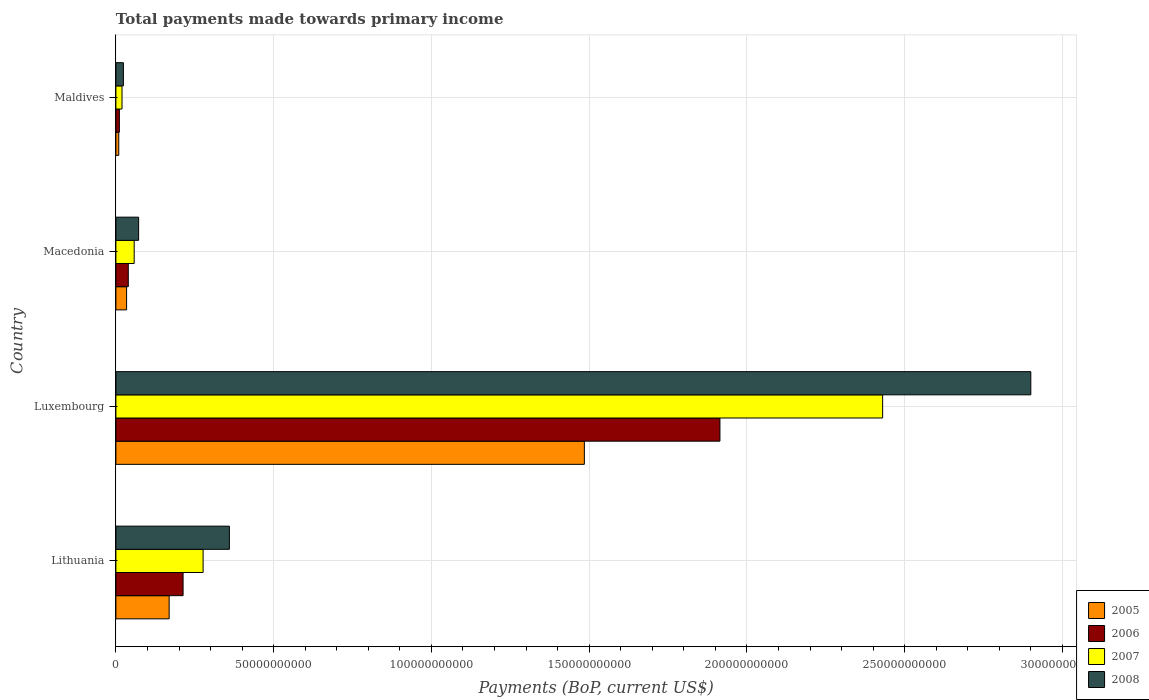How many groups of bars are there?
Offer a terse response. 4. Are the number of bars on each tick of the Y-axis equal?
Offer a very short reply. Yes. How many bars are there on the 4th tick from the top?
Offer a terse response. 4. How many bars are there on the 2nd tick from the bottom?
Give a very brief answer. 4. What is the label of the 2nd group of bars from the top?
Your answer should be compact. Macedonia. In how many cases, is the number of bars for a given country not equal to the number of legend labels?
Give a very brief answer. 0. What is the total payments made towards primary income in 2005 in Lithuania?
Keep it short and to the point. 1.69e+1. Across all countries, what is the maximum total payments made towards primary income in 2008?
Your response must be concise. 2.90e+11. Across all countries, what is the minimum total payments made towards primary income in 2008?
Make the answer very short. 2.38e+09. In which country was the total payments made towards primary income in 2007 maximum?
Make the answer very short. Luxembourg. In which country was the total payments made towards primary income in 2007 minimum?
Ensure brevity in your answer.  Maldives. What is the total total payments made towards primary income in 2005 in the graph?
Your answer should be very brief. 1.70e+11. What is the difference between the total payments made towards primary income in 2008 in Luxembourg and that in Macedonia?
Ensure brevity in your answer.  2.83e+11. What is the difference between the total payments made towards primary income in 2008 in Maldives and the total payments made towards primary income in 2006 in Lithuania?
Your response must be concise. -1.89e+1. What is the average total payments made towards primary income in 2005 per country?
Offer a terse response. 4.24e+1. What is the difference between the total payments made towards primary income in 2005 and total payments made towards primary income in 2006 in Luxembourg?
Make the answer very short. -4.30e+1. In how many countries, is the total payments made towards primary income in 2005 greater than 230000000000 US$?
Provide a short and direct response. 0. What is the ratio of the total payments made towards primary income in 2005 in Lithuania to that in Luxembourg?
Ensure brevity in your answer.  0.11. What is the difference between the highest and the second highest total payments made towards primary income in 2007?
Ensure brevity in your answer.  2.15e+11. What is the difference between the highest and the lowest total payments made towards primary income in 2006?
Your answer should be compact. 1.90e+11. In how many countries, is the total payments made towards primary income in 2005 greater than the average total payments made towards primary income in 2005 taken over all countries?
Keep it short and to the point. 1. Is the sum of the total payments made towards primary income in 2007 in Macedonia and Maldives greater than the maximum total payments made towards primary income in 2008 across all countries?
Ensure brevity in your answer.  No. What does the 1st bar from the bottom in Macedonia represents?
Offer a very short reply. 2005. Is it the case that in every country, the sum of the total payments made towards primary income in 2005 and total payments made towards primary income in 2008 is greater than the total payments made towards primary income in 2006?
Your response must be concise. Yes. How many bars are there?
Your answer should be compact. 16. Are all the bars in the graph horizontal?
Provide a succinct answer. Yes. What is the difference between two consecutive major ticks on the X-axis?
Offer a very short reply. 5.00e+1. Are the values on the major ticks of X-axis written in scientific E-notation?
Make the answer very short. No. Does the graph contain any zero values?
Offer a very short reply. No. Where does the legend appear in the graph?
Offer a very short reply. Bottom right. How are the legend labels stacked?
Your response must be concise. Vertical. What is the title of the graph?
Provide a short and direct response. Total payments made towards primary income. What is the label or title of the X-axis?
Provide a succinct answer. Payments (BoP, current US$). What is the label or title of the Y-axis?
Provide a succinct answer. Country. What is the Payments (BoP, current US$) in 2005 in Lithuania?
Ensure brevity in your answer.  1.69e+1. What is the Payments (BoP, current US$) of 2006 in Lithuania?
Ensure brevity in your answer.  2.13e+1. What is the Payments (BoP, current US$) of 2007 in Lithuania?
Your answer should be compact. 2.76e+1. What is the Payments (BoP, current US$) in 2008 in Lithuania?
Provide a succinct answer. 3.60e+1. What is the Payments (BoP, current US$) in 2005 in Luxembourg?
Give a very brief answer. 1.48e+11. What is the Payments (BoP, current US$) of 2006 in Luxembourg?
Provide a short and direct response. 1.91e+11. What is the Payments (BoP, current US$) of 2007 in Luxembourg?
Offer a terse response. 2.43e+11. What is the Payments (BoP, current US$) of 2008 in Luxembourg?
Give a very brief answer. 2.90e+11. What is the Payments (BoP, current US$) of 2005 in Macedonia?
Your response must be concise. 3.39e+09. What is the Payments (BoP, current US$) in 2006 in Macedonia?
Make the answer very short. 3.93e+09. What is the Payments (BoP, current US$) of 2007 in Macedonia?
Keep it short and to the point. 5.80e+09. What is the Payments (BoP, current US$) in 2008 in Macedonia?
Offer a terse response. 7.21e+09. What is the Payments (BoP, current US$) in 2005 in Maldives?
Ensure brevity in your answer.  9.10e+08. What is the Payments (BoP, current US$) of 2006 in Maldives?
Make the answer very short. 1.10e+09. What is the Payments (BoP, current US$) in 2007 in Maldives?
Your answer should be compact. 1.94e+09. What is the Payments (BoP, current US$) in 2008 in Maldives?
Provide a succinct answer. 2.38e+09. Across all countries, what is the maximum Payments (BoP, current US$) of 2005?
Offer a very short reply. 1.48e+11. Across all countries, what is the maximum Payments (BoP, current US$) in 2006?
Your response must be concise. 1.91e+11. Across all countries, what is the maximum Payments (BoP, current US$) in 2007?
Ensure brevity in your answer.  2.43e+11. Across all countries, what is the maximum Payments (BoP, current US$) in 2008?
Your response must be concise. 2.90e+11. Across all countries, what is the minimum Payments (BoP, current US$) in 2005?
Ensure brevity in your answer.  9.10e+08. Across all countries, what is the minimum Payments (BoP, current US$) in 2006?
Your response must be concise. 1.10e+09. Across all countries, what is the minimum Payments (BoP, current US$) of 2007?
Make the answer very short. 1.94e+09. Across all countries, what is the minimum Payments (BoP, current US$) of 2008?
Provide a succinct answer. 2.38e+09. What is the total Payments (BoP, current US$) in 2005 in the graph?
Provide a short and direct response. 1.70e+11. What is the total Payments (BoP, current US$) in 2006 in the graph?
Your answer should be very brief. 2.18e+11. What is the total Payments (BoP, current US$) of 2007 in the graph?
Offer a very short reply. 2.78e+11. What is the total Payments (BoP, current US$) of 2008 in the graph?
Ensure brevity in your answer.  3.36e+11. What is the difference between the Payments (BoP, current US$) of 2005 in Lithuania and that in Luxembourg?
Make the answer very short. -1.32e+11. What is the difference between the Payments (BoP, current US$) in 2006 in Lithuania and that in Luxembourg?
Keep it short and to the point. -1.70e+11. What is the difference between the Payments (BoP, current US$) in 2007 in Lithuania and that in Luxembourg?
Ensure brevity in your answer.  -2.15e+11. What is the difference between the Payments (BoP, current US$) in 2008 in Lithuania and that in Luxembourg?
Offer a terse response. -2.54e+11. What is the difference between the Payments (BoP, current US$) in 2005 in Lithuania and that in Macedonia?
Your answer should be very brief. 1.35e+1. What is the difference between the Payments (BoP, current US$) in 2006 in Lithuania and that in Macedonia?
Make the answer very short. 1.74e+1. What is the difference between the Payments (BoP, current US$) of 2007 in Lithuania and that in Macedonia?
Keep it short and to the point. 2.18e+1. What is the difference between the Payments (BoP, current US$) of 2008 in Lithuania and that in Macedonia?
Offer a terse response. 2.88e+1. What is the difference between the Payments (BoP, current US$) of 2005 in Lithuania and that in Maldives?
Make the answer very short. 1.60e+1. What is the difference between the Payments (BoP, current US$) in 2006 in Lithuania and that in Maldives?
Ensure brevity in your answer.  2.02e+1. What is the difference between the Payments (BoP, current US$) in 2007 in Lithuania and that in Maldives?
Offer a terse response. 2.57e+1. What is the difference between the Payments (BoP, current US$) in 2008 in Lithuania and that in Maldives?
Keep it short and to the point. 3.36e+1. What is the difference between the Payments (BoP, current US$) of 2005 in Luxembourg and that in Macedonia?
Provide a succinct answer. 1.45e+11. What is the difference between the Payments (BoP, current US$) of 2006 in Luxembourg and that in Macedonia?
Offer a very short reply. 1.87e+11. What is the difference between the Payments (BoP, current US$) of 2007 in Luxembourg and that in Macedonia?
Offer a very short reply. 2.37e+11. What is the difference between the Payments (BoP, current US$) of 2008 in Luxembourg and that in Macedonia?
Your answer should be very brief. 2.83e+11. What is the difference between the Payments (BoP, current US$) in 2005 in Luxembourg and that in Maldives?
Provide a succinct answer. 1.48e+11. What is the difference between the Payments (BoP, current US$) in 2006 in Luxembourg and that in Maldives?
Offer a very short reply. 1.90e+11. What is the difference between the Payments (BoP, current US$) in 2007 in Luxembourg and that in Maldives?
Offer a terse response. 2.41e+11. What is the difference between the Payments (BoP, current US$) in 2008 in Luxembourg and that in Maldives?
Provide a succinct answer. 2.88e+11. What is the difference between the Payments (BoP, current US$) of 2005 in Macedonia and that in Maldives?
Provide a succinct answer. 2.48e+09. What is the difference between the Payments (BoP, current US$) of 2006 in Macedonia and that in Maldives?
Offer a very short reply. 2.83e+09. What is the difference between the Payments (BoP, current US$) of 2007 in Macedonia and that in Maldives?
Offer a terse response. 3.86e+09. What is the difference between the Payments (BoP, current US$) of 2008 in Macedonia and that in Maldives?
Provide a succinct answer. 4.83e+09. What is the difference between the Payments (BoP, current US$) in 2005 in Lithuania and the Payments (BoP, current US$) in 2006 in Luxembourg?
Offer a very short reply. -1.75e+11. What is the difference between the Payments (BoP, current US$) of 2005 in Lithuania and the Payments (BoP, current US$) of 2007 in Luxembourg?
Give a very brief answer. -2.26e+11. What is the difference between the Payments (BoP, current US$) in 2005 in Lithuania and the Payments (BoP, current US$) in 2008 in Luxembourg?
Keep it short and to the point. -2.73e+11. What is the difference between the Payments (BoP, current US$) of 2006 in Lithuania and the Payments (BoP, current US$) of 2007 in Luxembourg?
Give a very brief answer. -2.22e+11. What is the difference between the Payments (BoP, current US$) in 2006 in Lithuania and the Payments (BoP, current US$) in 2008 in Luxembourg?
Your response must be concise. -2.69e+11. What is the difference between the Payments (BoP, current US$) of 2007 in Lithuania and the Payments (BoP, current US$) of 2008 in Luxembourg?
Make the answer very short. -2.62e+11. What is the difference between the Payments (BoP, current US$) in 2005 in Lithuania and the Payments (BoP, current US$) in 2006 in Macedonia?
Your answer should be very brief. 1.29e+1. What is the difference between the Payments (BoP, current US$) of 2005 in Lithuania and the Payments (BoP, current US$) of 2007 in Macedonia?
Keep it short and to the point. 1.11e+1. What is the difference between the Payments (BoP, current US$) in 2005 in Lithuania and the Payments (BoP, current US$) in 2008 in Macedonia?
Make the answer very short. 9.67e+09. What is the difference between the Payments (BoP, current US$) of 2006 in Lithuania and the Payments (BoP, current US$) of 2007 in Macedonia?
Your response must be concise. 1.55e+1. What is the difference between the Payments (BoP, current US$) in 2006 in Lithuania and the Payments (BoP, current US$) in 2008 in Macedonia?
Offer a very short reply. 1.41e+1. What is the difference between the Payments (BoP, current US$) in 2007 in Lithuania and the Payments (BoP, current US$) in 2008 in Macedonia?
Provide a succinct answer. 2.04e+1. What is the difference between the Payments (BoP, current US$) in 2005 in Lithuania and the Payments (BoP, current US$) in 2006 in Maldives?
Offer a very short reply. 1.58e+1. What is the difference between the Payments (BoP, current US$) of 2005 in Lithuania and the Payments (BoP, current US$) of 2007 in Maldives?
Keep it short and to the point. 1.49e+1. What is the difference between the Payments (BoP, current US$) of 2005 in Lithuania and the Payments (BoP, current US$) of 2008 in Maldives?
Offer a terse response. 1.45e+1. What is the difference between the Payments (BoP, current US$) of 2006 in Lithuania and the Payments (BoP, current US$) of 2007 in Maldives?
Give a very brief answer. 1.93e+1. What is the difference between the Payments (BoP, current US$) in 2006 in Lithuania and the Payments (BoP, current US$) in 2008 in Maldives?
Your answer should be very brief. 1.89e+1. What is the difference between the Payments (BoP, current US$) in 2007 in Lithuania and the Payments (BoP, current US$) in 2008 in Maldives?
Your response must be concise. 2.53e+1. What is the difference between the Payments (BoP, current US$) of 2005 in Luxembourg and the Payments (BoP, current US$) of 2006 in Macedonia?
Keep it short and to the point. 1.45e+11. What is the difference between the Payments (BoP, current US$) in 2005 in Luxembourg and the Payments (BoP, current US$) in 2007 in Macedonia?
Your answer should be very brief. 1.43e+11. What is the difference between the Payments (BoP, current US$) in 2005 in Luxembourg and the Payments (BoP, current US$) in 2008 in Macedonia?
Your answer should be very brief. 1.41e+11. What is the difference between the Payments (BoP, current US$) of 2006 in Luxembourg and the Payments (BoP, current US$) of 2007 in Macedonia?
Your response must be concise. 1.86e+11. What is the difference between the Payments (BoP, current US$) in 2006 in Luxembourg and the Payments (BoP, current US$) in 2008 in Macedonia?
Keep it short and to the point. 1.84e+11. What is the difference between the Payments (BoP, current US$) in 2007 in Luxembourg and the Payments (BoP, current US$) in 2008 in Macedonia?
Keep it short and to the point. 2.36e+11. What is the difference between the Payments (BoP, current US$) of 2005 in Luxembourg and the Payments (BoP, current US$) of 2006 in Maldives?
Your response must be concise. 1.47e+11. What is the difference between the Payments (BoP, current US$) of 2005 in Luxembourg and the Payments (BoP, current US$) of 2007 in Maldives?
Offer a very short reply. 1.47e+11. What is the difference between the Payments (BoP, current US$) of 2005 in Luxembourg and the Payments (BoP, current US$) of 2008 in Maldives?
Provide a succinct answer. 1.46e+11. What is the difference between the Payments (BoP, current US$) in 2006 in Luxembourg and the Payments (BoP, current US$) in 2007 in Maldives?
Your answer should be compact. 1.89e+11. What is the difference between the Payments (BoP, current US$) in 2006 in Luxembourg and the Payments (BoP, current US$) in 2008 in Maldives?
Make the answer very short. 1.89e+11. What is the difference between the Payments (BoP, current US$) of 2007 in Luxembourg and the Payments (BoP, current US$) of 2008 in Maldives?
Your answer should be compact. 2.41e+11. What is the difference between the Payments (BoP, current US$) in 2005 in Macedonia and the Payments (BoP, current US$) in 2006 in Maldives?
Give a very brief answer. 2.29e+09. What is the difference between the Payments (BoP, current US$) of 2005 in Macedonia and the Payments (BoP, current US$) of 2007 in Maldives?
Keep it short and to the point. 1.45e+09. What is the difference between the Payments (BoP, current US$) of 2005 in Macedonia and the Payments (BoP, current US$) of 2008 in Maldives?
Your response must be concise. 1.01e+09. What is the difference between the Payments (BoP, current US$) in 2006 in Macedonia and the Payments (BoP, current US$) in 2007 in Maldives?
Your response must be concise. 1.99e+09. What is the difference between the Payments (BoP, current US$) of 2006 in Macedonia and the Payments (BoP, current US$) of 2008 in Maldives?
Your answer should be very brief. 1.55e+09. What is the difference between the Payments (BoP, current US$) of 2007 in Macedonia and the Payments (BoP, current US$) of 2008 in Maldives?
Offer a terse response. 3.42e+09. What is the average Payments (BoP, current US$) in 2005 per country?
Offer a very short reply. 4.24e+1. What is the average Payments (BoP, current US$) of 2006 per country?
Make the answer very short. 5.44e+1. What is the average Payments (BoP, current US$) in 2007 per country?
Ensure brevity in your answer.  6.96e+1. What is the average Payments (BoP, current US$) of 2008 per country?
Give a very brief answer. 8.39e+1. What is the difference between the Payments (BoP, current US$) in 2005 and Payments (BoP, current US$) in 2006 in Lithuania?
Your answer should be very brief. -4.41e+09. What is the difference between the Payments (BoP, current US$) of 2005 and Payments (BoP, current US$) of 2007 in Lithuania?
Provide a succinct answer. -1.08e+1. What is the difference between the Payments (BoP, current US$) in 2005 and Payments (BoP, current US$) in 2008 in Lithuania?
Offer a very short reply. -1.91e+1. What is the difference between the Payments (BoP, current US$) in 2006 and Payments (BoP, current US$) in 2007 in Lithuania?
Your answer should be compact. -6.35e+09. What is the difference between the Payments (BoP, current US$) in 2006 and Payments (BoP, current US$) in 2008 in Lithuania?
Your answer should be compact. -1.47e+1. What is the difference between the Payments (BoP, current US$) in 2007 and Payments (BoP, current US$) in 2008 in Lithuania?
Your answer should be compact. -8.33e+09. What is the difference between the Payments (BoP, current US$) of 2005 and Payments (BoP, current US$) of 2006 in Luxembourg?
Your answer should be compact. -4.30e+1. What is the difference between the Payments (BoP, current US$) in 2005 and Payments (BoP, current US$) in 2007 in Luxembourg?
Your answer should be compact. -9.45e+1. What is the difference between the Payments (BoP, current US$) of 2005 and Payments (BoP, current US$) of 2008 in Luxembourg?
Your answer should be very brief. -1.41e+11. What is the difference between the Payments (BoP, current US$) of 2006 and Payments (BoP, current US$) of 2007 in Luxembourg?
Your answer should be compact. -5.16e+1. What is the difference between the Payments (BoP, current US$) in 2006 and Payments (BoP, current US$) in 2008 in Luxembourg?
Give a very brief answer. -9.85e+1. What is the difference between the Payments (BoP, current US$) in 2007 and Payments (BoP, current US$) in 2008 in Luxembourg?
Your answer should be very brief. -4.70e+1. What is the difference between the Payments (BoP, current US$) of 2005 and Payments (BoP, current US$) of 2006 in Macedonia?
Ensure brevity in your answer.  -5.40e+08. What is the difference between the Payments (BoP, current US$) of 2005 and Payments (BoP, current US$) of 2007 in Macedonia?
Your answer should be very brief. -2.41e+09. What is the difference between the Payments (BoP, current US$) of 2005 and Payments (BoP, current US$) of 2008 in Macedonia?
Your response must be concise. -3.81e+09. What is the difference between the Payments (BoP, current US$) of 2006 and Payments (BoP, current US$) of 2007 in Macedonia?
Your answer should be compact. -1.87e+09. What is the difference between the Payments (BoP, current US$) of 2006 and Payments (BoP, current US$) of 2008 in Macedonia?
Give a very brief answer. -3.27e+09. What is the difference between the Payments (BoP, current US$) of 2007 and Payments (BoP, current US$) of 2008 in Macedonia?
Provide a short and direct response. -1.41e+09. What is the difference between the Payments (BoP, current US$) in 2005 and Payments (BoP, current US$) in 2006 in Maldives?
Your answer should be very brief. -1.92e+08. What is the difference between the Payments (BoP, current US$) in 2005 and Payments (BoP, current US$) in 2007 in Maldives?
Your answer should be compact. -1.03e+09. What is the difference between the Payments (BoP, current US$) of 2005 and Payments (BoP, current US$) of 2008 in Maldives?
Provide a short and direct response. -1.47e+09. What is the difference between the Payments (BoP, current US$) in 2006 and Payments (BoP, current US$) in 2007 in Maldives?
Your answer should be very brief. -8.40e+08. What is the difference between the Payments (BoP, current US$) of 2006 and Payments (BoP, current US$) of 2008 in Maldives?
Make the answer very short. -1.28e+09. What is the difference between the Payments (BoP, current US$) in 2007 and Payments (BoP, current US$) in 2008 in Maldives?
Keep it short and to the point. -4.38e+08. What is the ratio of the Payments (BoP, current US$) in 2005 in Lithuania to that in Luxembourg?
Ensure brevity in your answer.  0.11. What is the ratio of the Payments (BoP, current US$) of 2006 in Lithuania to that in Luxembourg?
Your answer should be very brief. 0.11. What is the ratio of the Payments (BoP, current US$) of 2007 in Lithuania to that in Luxembourg?
Offer a very short reply. 0.11. What is the ratio of the Payments (BoP, current US$) in 2008 in Lithuania to that in Luxembourg?
Make the answer very short. 0.12. What is the ratio of the Payments (BoP, current US$) in 2005 in Lithuania to that in Macedonia?
Offer a very short reply. 4.98. What is the ratio of the Payments (BoP, current US$) of 2006 in Lithuania to that in Macedonia?
Provide a short and direct response. 5.41. What is the ratio of the Payments (BoP, current US$) of 2007 in Lithuania to that in Macedonia?
Give a very brief answer. 4.77. What is the ratio of the Payments (BoP, current US$) in 2008 in Lithuania to that in Macedonia?
Your response must be concise. 4.99. What is the ratio of the Payments (BoP, current US$) of 2005 in Lithuania to that in Maldives?
Ensure brevity in your answer.  18.54. What is the ratio of the Payments (BoP, current US$) of 2006 in Lithuania to that in Maldives?
Keep it short and to the point. 19.31. What is the ratio of the Payments (BoP, current US$) in 2007 in Lithuania to that in Maldives?
Your response must be concise. 14.23. What is the ratio of the Payments (BoP, current US$) in 2008 in Lithuania to that in Maldives?
Your response must be concise. 15.11. What is the ratio of the Payments (BoP, current US$) of 2005 in Luxembourg to that in Macedonia?
Your answer should be compact. 43.76. What is the ratio of the Payments (BoP, current US$) of 2006 in Luxembourg to that in Macedonia?
Give a very brief answer. 48.68. What is the ratio of the Payments (BoP, current US$) in 2007 in Luxembourg to that in Macedonia?
Offer a very short reply. 41.91. What is the ratio of the Payments (BoP, current US$) in 2008 in Luxembourg to that in Macedonia?
Your answer should be very brief. 40.24. What is the ratio of the Payments (BoP, current US$) of 2005 in Luxembourg to that in Maldives?
Offer a terse response. 163.08. What is the ratio of the Payments (BoP, current US$) in 2006 in Luxembourg to that in Maldives?
Provide a succinct answer. 173.58. What is the ratio of the Payments (BoP, current US$) of 2007 in Luxembourg to that in Maldives?
Offer a very short reply. 125.06. What is the ratio of the Payments (BoP, current US$) of 2008 in Luxembourg to that in Maldives?
Keep it short and to the point. 121.79. What is the ratio of the Payments (BoP, current US$) of 2005 in Macedonia to that in Maldives?
Offer a very short reply. 3.73. What is the ratio of the Payments (BoP, current US$) in 2006 in Macedonia to that in Maldives?
Your answer should be compact. 3.57. What is the ratio of the Payments (BoP, current US$) of 2007 in Macedonia to that in Maldives?
Your response must be concise. 2.98. What is the ratio of the Payments (BoP, current US$) of 2008 in Macedonia to that in Maldives?
Ensure brevity in your answer.  3.03. What is the difference between the highest and the second highest Payments (BoP, current US$) of 2005?
Provide a short and direct response. 1.32e+11. What is the difference between the highest and the second highest Payments (BoP, current US$) of 2006?
Your answer should be very brief. 1.70e+11. What is the difference between the highest and the second highest Payments (BoP, current US$) in 2007?
Keep it short and to the point. 2.15e+11. What is the difference between the highest and the second highest Payments (BoP, current US$) of 2008?
Ensure brevity in your answer.  2.54e+11. What is the difference between the highest and the lowest Payments (BoP, current US$) of 2005?
Provide a succinct answer. 1.48e+11. What is the difference between the highest and the lowest Payments (BoP, current US$) of 2006?
Give a very brief answer. 1.90e+11. What is the difference between the highest and the lowest Payments (BoP, current US$) in 2007?
Offer a terse response. 2.41e+11. What is the difference between the highest and the lowest Payments (BoP, current US$) of 2008?
Make the answer very short. 2.88e+11. 